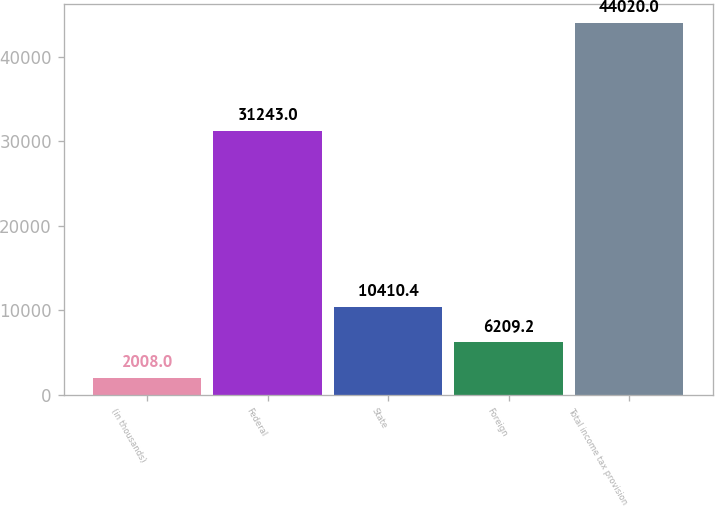Convert chart. <chart><loc_0><loc_0><loc_500><loc_500><bar_chart><fcel>(in thousands)<fcel>Federal<fcel>State<fcel>Foreign<fcel>Total income tax provision<nl><fcel>2008<fcel>31243<fcel>10410.4<fcel>6209.2<fcel>44020<nl></chart> 